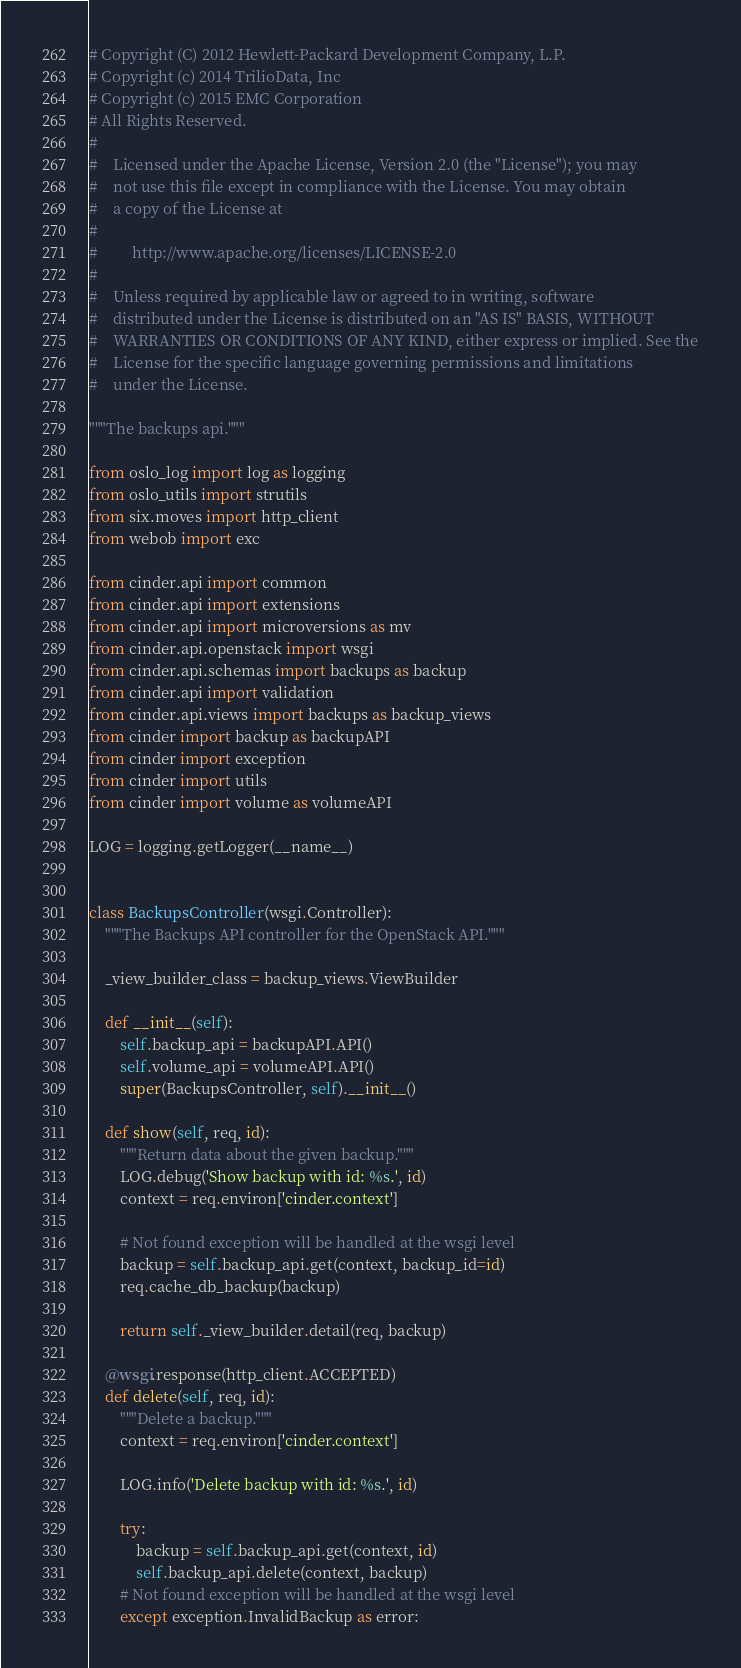<code> <loc_0><loc_0><loc_500><loc_500><_Python_># Copyright (C) 2012 Hewlett-Packard Development Company, L.P.
# Copyright (c) 2014 TrilioData, Inc
# Copyright (c) 2015 EMC Corporation
# All Rights Reserved.
#
#    Licensed under the Apache License, Version 2.0 (the "License"); you may
#    not use this file except in compliance with the License. You may obtain
#    a copy of the License at
#
#         http://www.apache.org/licenses/LICENSE-2.0
#
#    Unless required by applicable law or agreed to in writing, software
#    distributed under the License is distributed on an "AS IS" BASIS, WITHOUT
#    WARRANTIES OR CONDITIONS OF ANY KIND, either express or implied. See the
#    License for the specific language governing permissions and limitations
#    under the License.

"""The backups api."""

from oslo_log import log as logging
from oslo_utils import strutils
from six.moves import http_client
from webob import exc

from cinder.api import common
from cinder.api import extensions
from cinder.api import microversions as mv
from cinder.api.openstack import wsgi
from cinder.api.schemas import backups as backup
from cinder.api import validation
from cinder.api.views import backups as backup_views
from cinder import backup as backupAPI
from cinder import exception
from cinder import utils
from cinder import volume as volumeAPI

LOG = logging.getLogger(__name__)


class BackupsController(wsgi.Controller):
    """The Backups API controller for the OpenStack API."""

    _view_builder_class = backup_views.ViewBuilder

    def __init__(self):
        self.backup_api = backupAPI.API()
        self.volume_api = volumeAPI.API()
        super(BackupsController, self).__init__()

    def show(self, req, id):
        """Return data about the given backup."""
        LOG.debug('Show backup with id: %s.', id)
        context = req.environ['cinder.context']

        # Not found exception will be handled at the wsgi level
        backup = self.backup_api.get(context, backup_id=id)
        req.cache_db_backup(backup)

        return self._view_builder.detail(req, backup)

    @wsgi.response(http_client.ACCEPTED)
    def delete(self, req, id):
        """Delete a backup."""
        context = req.environ['cinder.context']

        LOG.info('Delete backup with id: %s.', id)

        try:
            backup = self.backup_api.get(context, id)
            self.backup_api.delete(context, backup)
        # Not found exception will be handled at the wsgi level
        except exception.InvalidBackup as error:</code> 